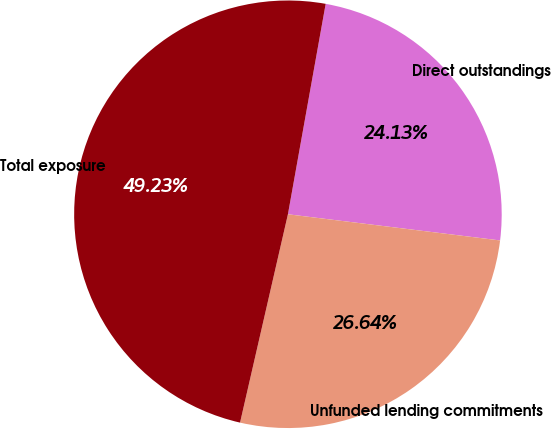<chart> <loc_0><loc_0><loc_500><loc_500><pie_chart><fcel>Direct outstandings<fcel>Unfunded lending commitments<fcel>Total exposure<nl><fcel>24.13%<fcel>26.64%<fcel>49.23%<nl></chart> 